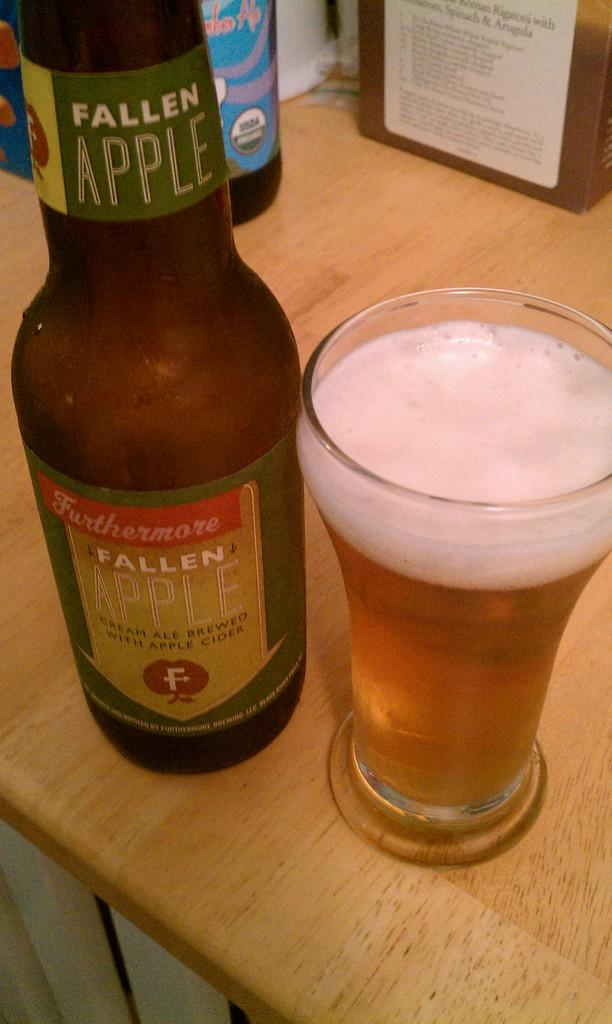<image>
Write a terse but informative summary of the picture. A glass of fallen apple cider sits on a table next to its bottle. 